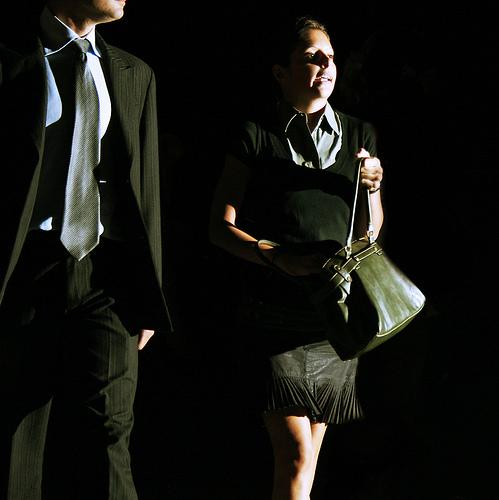What is the person on the left wearing? suit 